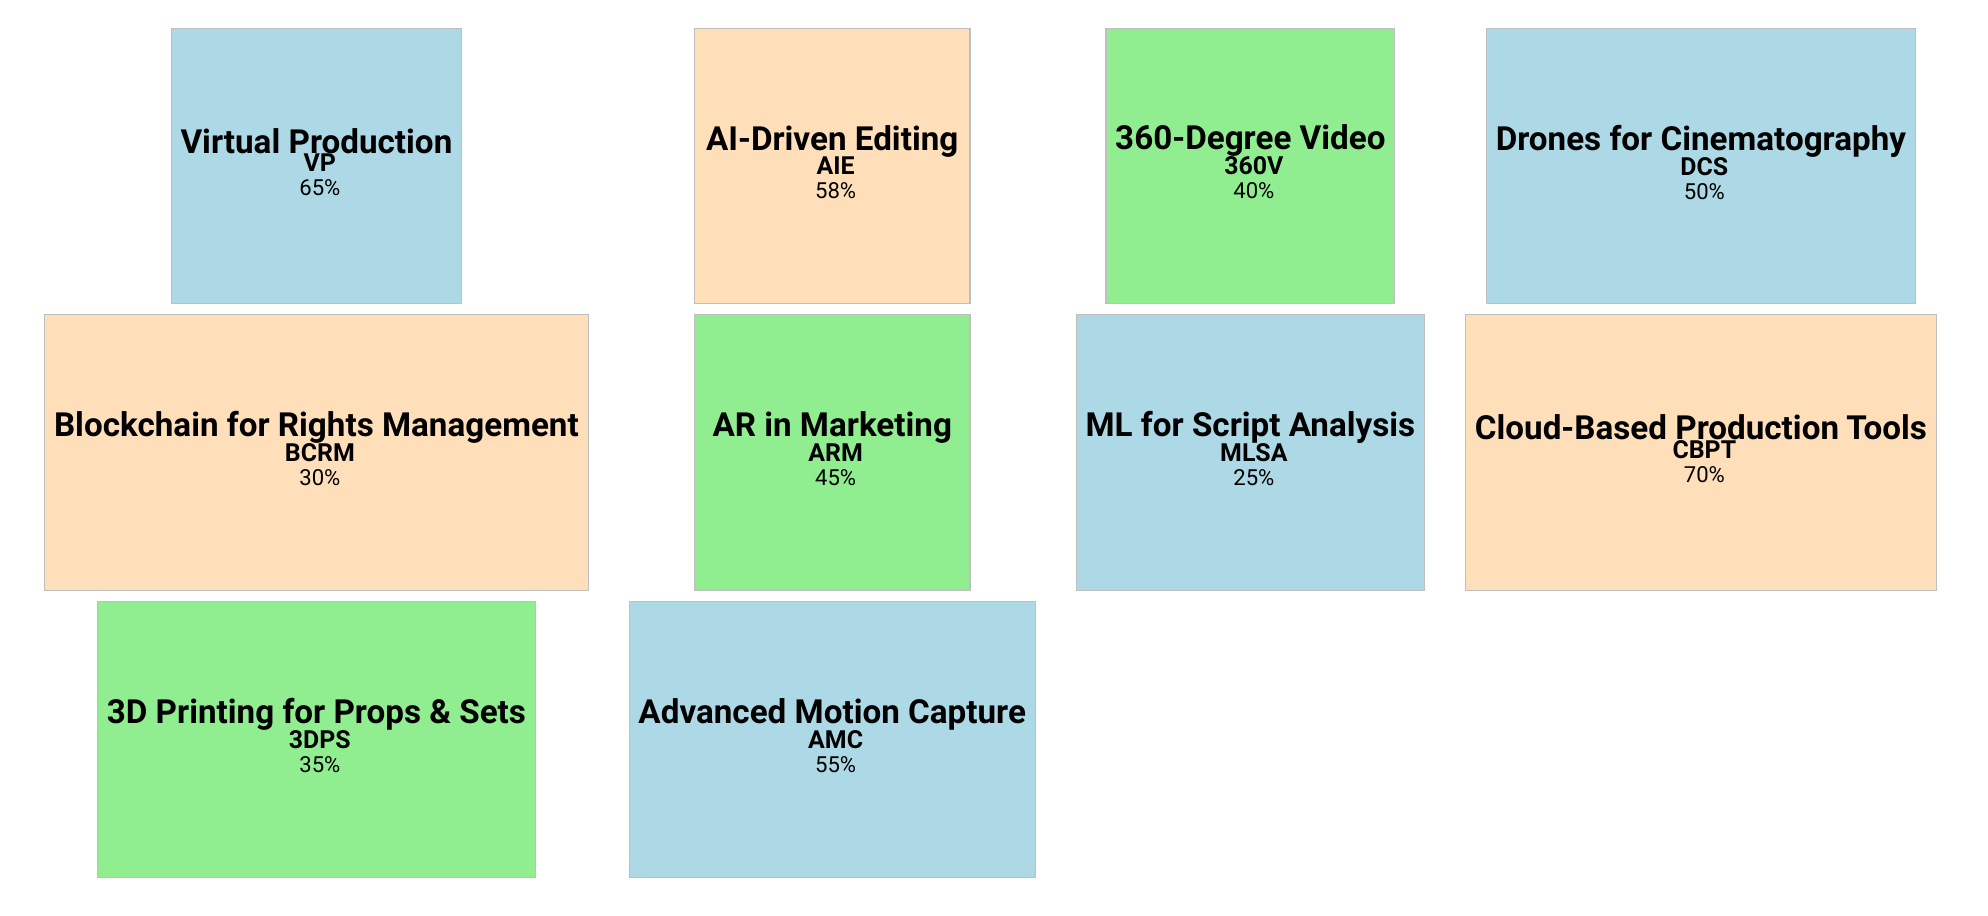What is the adoption rate of Virtual Production? The table shows that the adoption rate of Virtual Production is displayed directly under the "adoption rate" column. It states 65%.
Answer: 65% Which emerging technology has the highest adoption rate? By comparing the adoption rates listed in the table, the highest rate is for Cloud-Based Production Tools with an adoption rate of 70%.
Answer: Cloud-Based Production Tools Is the adoption rate of AI-Driven Editing higher than that of Augmented Reality in Marketing? The adoption rate for AI-Driven Editing is 58%, and for Augmented Reality in Marketing, it is 45%. Since 58% is greater than 45%, the answer is yes.
Answer: Yes What is the average adoption rate of the technologies that have an adoption rate below 50%? The technologies with adoption rates below 50% are Blockchain for Rights Management (30%), 360-Degree Video (40%), and Machine Learning for Script Analysis (25%). The average adoption rate is calculated as (30 + 40 + 25) / 3 = 95 / 3 = 31.67.
Answer: 31.67% Does 3D Printing for Props & Sets have more benefits than Drones for Cinematography? 3D Printing for Props & Sets has three benefits listed, while Drones for Cinematography also has three benefits listed. Since both technologies have the same number of benefits, the answer is no.
Answer: No 